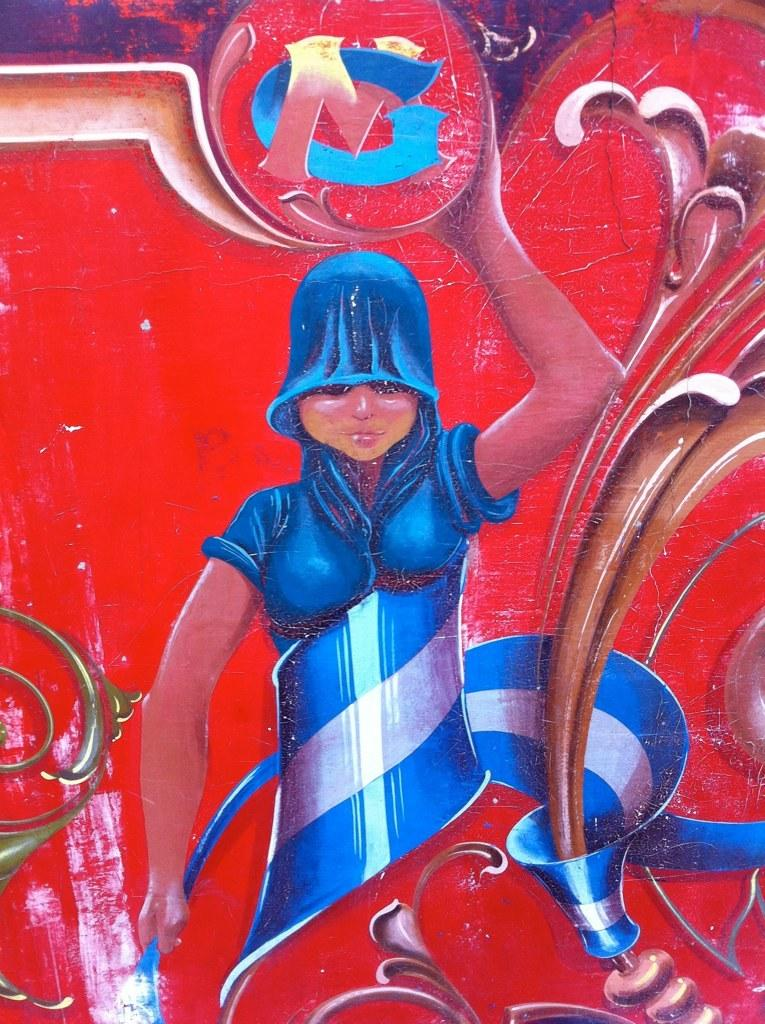What type of visual content is depicted in the image? The image is a poster. Can you describe the main subject of the poster? There is a person in the poster. What is the person in the poster doing? The person is holding an object in their hand. How many flowers are being held by the ghost in the image? There is no ghost present in the image, and therefore no flowers being held by a ghost. 